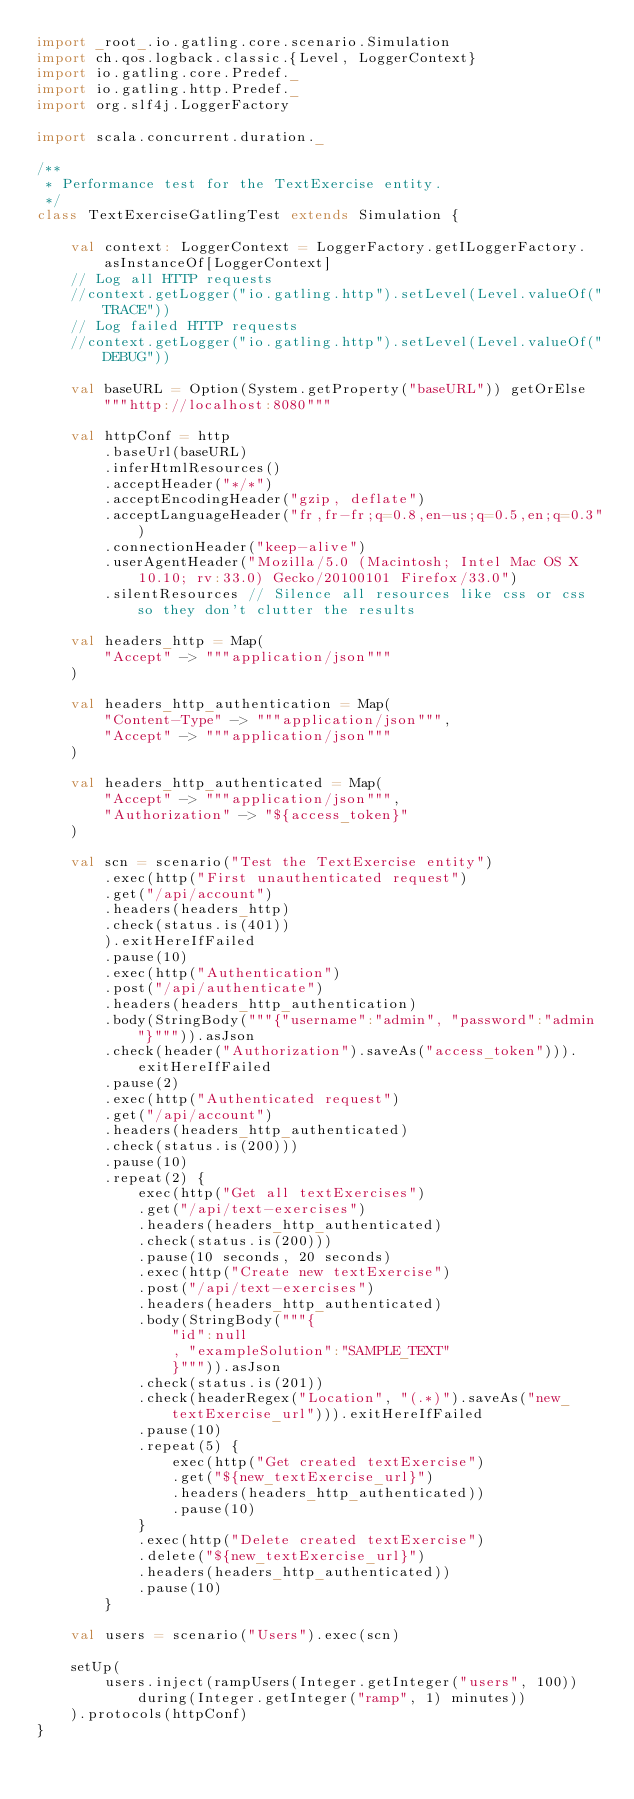Convert code to text. <code><loc_0><loc_0><loc_500><loc_500><_Scala_>import _root_.io.gatling.core.scenario.Simulation
import ch.qos.logback.classic.{Level, LoggerContext}
import io.gatling.core.Predef._
import io.gatling.http.Predef._
import org.slf4j.LoggerFactory

import scala.concurrent.duration._

/**
 * Performance test for the TextExercise entity.
 */
class TextExerciseGatlingTest extends Simulation {

    val context: LoggerContext = LoggerFactory.getILoggerFactory.asInstanceOf[LoggerContext]
    // Log all HTTP requests
    //context.getLogger("io.gatling.http").setLevel(Level.valueOf("TRACE"))
    // Log failed HTTP requests
    //context.getLogger("io.gatling.http").setLevel(Level.valueOf("DEBUG"))

    val baseURL = Option(System.getProperty("baseURL")) getOrElse """http://localhost:8080"""

    val httpConf = http
        .baseUrl(baseURL)
        .inferHtmlResources()
        .acceptHeader("*/*")
        .acceptEncodingHeader("gzip, deflate")
        .acceptLanguageHeader("fr,fr-fr;q=0.8,en-us;q=0.5,en;q=0.3")
        .connectionHeader("keep-alive")
        .userAgentHeader("Mozilla/5.0 (Macintosh; Intel Mac OS X 10.10; rv:33.0) Gecko/20100101 Firefox/33.0")
        .silentResources // Silence all resources like css or css so they don't clutter the results

    val headers_http = Map(
        "Accept" -> """application/json"""
    )

    val headers_http_authentication = Map(
        "Content-Type" -> """application/json""",
        "Accept" -> """application/json"""
    )

    val headers_http_authenticated = Map(
        "Accept" -> """application/json""",
        "Authorization" -> "${access_token}"
    )

    val scn = scenario("Test the TextExercise entity")
        .exec(http("First unauthenticated request")
        .get("/api/account")
        .headers(headers_http)
        .check(status.is(401))
        ).exitHereIfFailed
        .pause(10)
        .exec(http("Authentication")
        .post("/api/authenticate")
        .headers(headers_http_authentication)
        .body(StringBody("""{"username":"admin", "password":"admin"}""")).asJson
        .check(header("Authorization").saveAs("access_token"))).exitHereIfFailed
        .pause(2)
        .exec(http("Authenticated request")
        .get("/api/account")
        .headers(headers_http_authenticated)
        .check(status.is(200)))
        .pause(10)
        .repeat(2) {
            exec(http("Get all textExercises")
            .get("/api/text-exercises")
            .headers(headers_http_authenticated)
            .check(status.is(200)))
            .pause(10 seconds, 20 seconds)
            .exec(http("Create new textExercise")
            .post("/api/text-exercises")
            .headers(headers_http_authenticated)
            .body(StringBody("""{
                "id":null
                , "exampleSolution":"SAMPLE_TEXT"
                }""")).asJson
            .check(status.is(201))
            .check(headerRegex("Location", "(.*)").saveAs("new_textExercise_url"))).exitHereIfFailed
            .pause(10)
            .repeat(5) {
                exec(http("Get created textExercise")
                .get("${new_textExercise_url}")
                .headers(headers_http_authenticated))
                .pause(10)
            }
            .exec(http("Delete created textExercise")
            .delete("${new_textExercise_url}")
            .headers(headers_http_authenticated))
            .pause(10)
        }

    val users = scenario("Users").exec(scn)

    setUp(
        users.inject(rampUsers(Integer.getInteger("users", 100)) during(Integer.getInteger("ramp", 1) minutes))
    ).protocols(httpConf)
}
</code> 